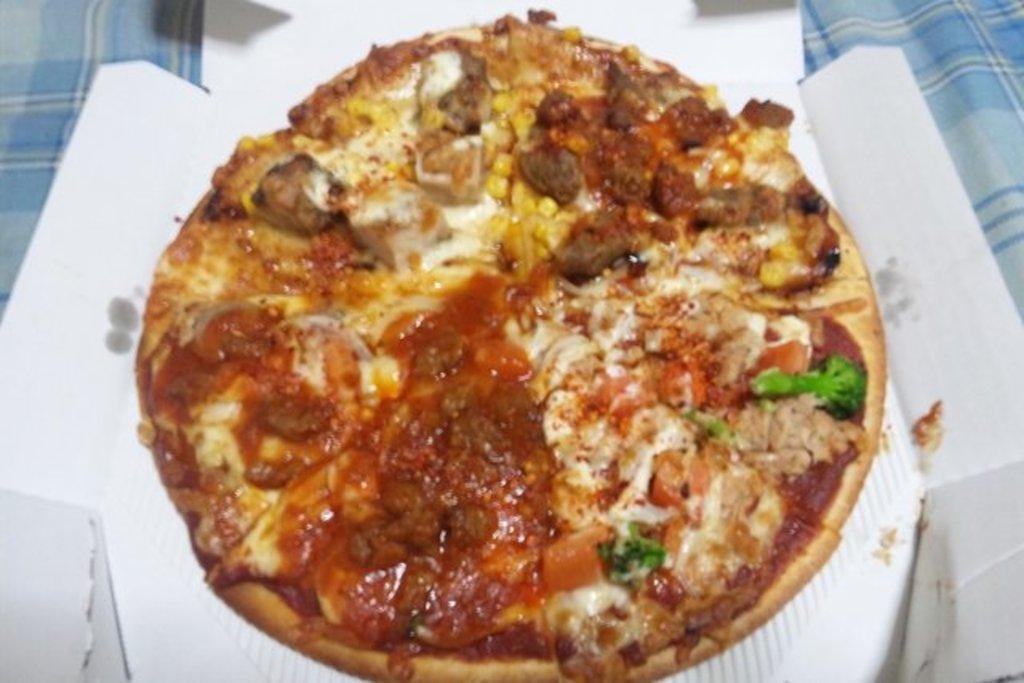Describe this image in one or two sentences. In this picture there is a pizza on the white box. At the bottom there is a sky blue and white cloth. 